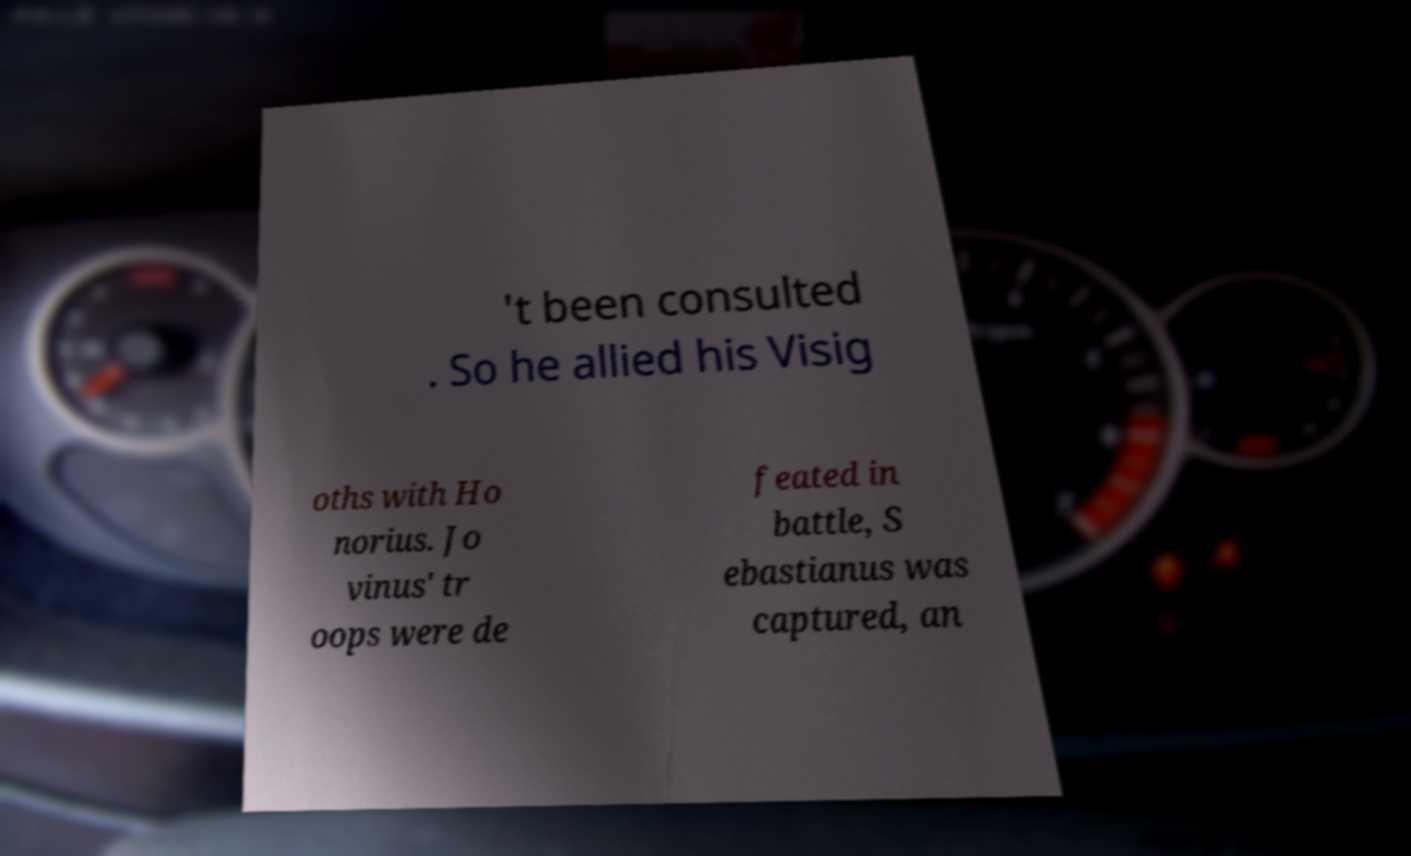There's text embedded in this image that I need extracted. Can you transcribe it verbatim? 't been consulted . So he allied his Visig oths with Ho norius. Jo vinus' tr oops were de feated in battle, S ebastianus was captured, an 